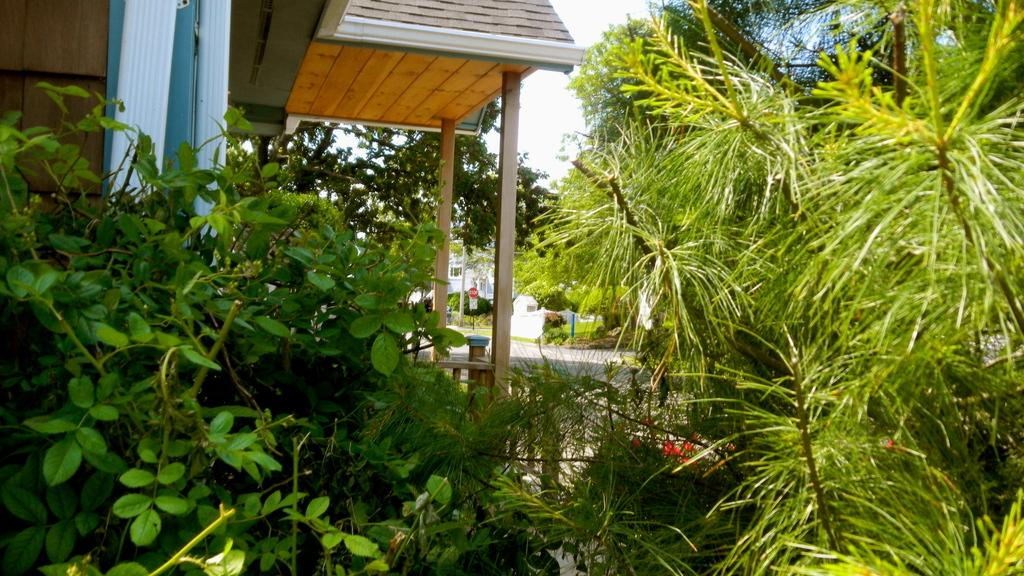What type of vegetation can be seen in the image? There are trees in the image. What type of structures are present in the image? There are buildings in the image. What is visible in the background of the image? The sky is visible in the background of the image. Can you tell me how many cows are grazing in the image? There are no cows present in the image; it features trees and buildings. What type of material is used to make the trees in the image? The image does not contain a silk tree; it features regular trees. 